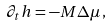Convert formula to latex. <formula><loc_0><loc_0><loc_500><loc_500>\partial _ { t } h = - M \Delta \mu \, ,</formula> 